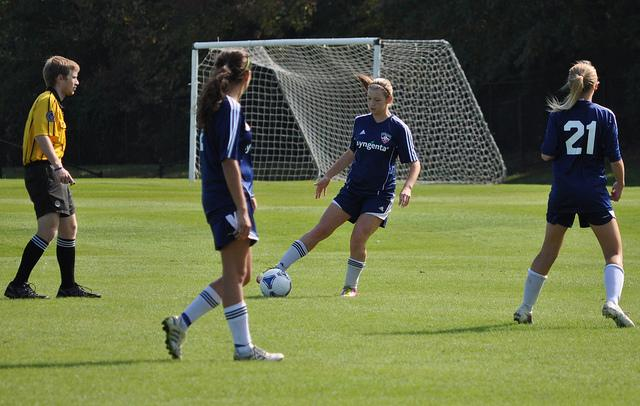Who will try to get the ball from the person who touches it? opponent 